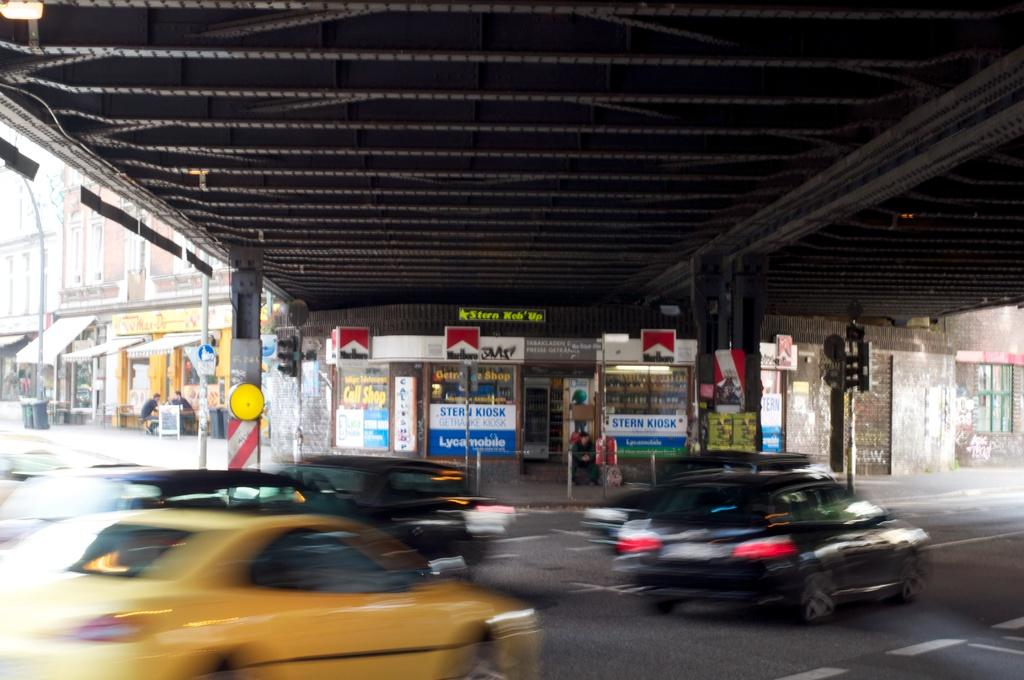Provide a one-sentence caption for the provided image. Marlboro cigarettes are availabe at the store underneath the bridge. 